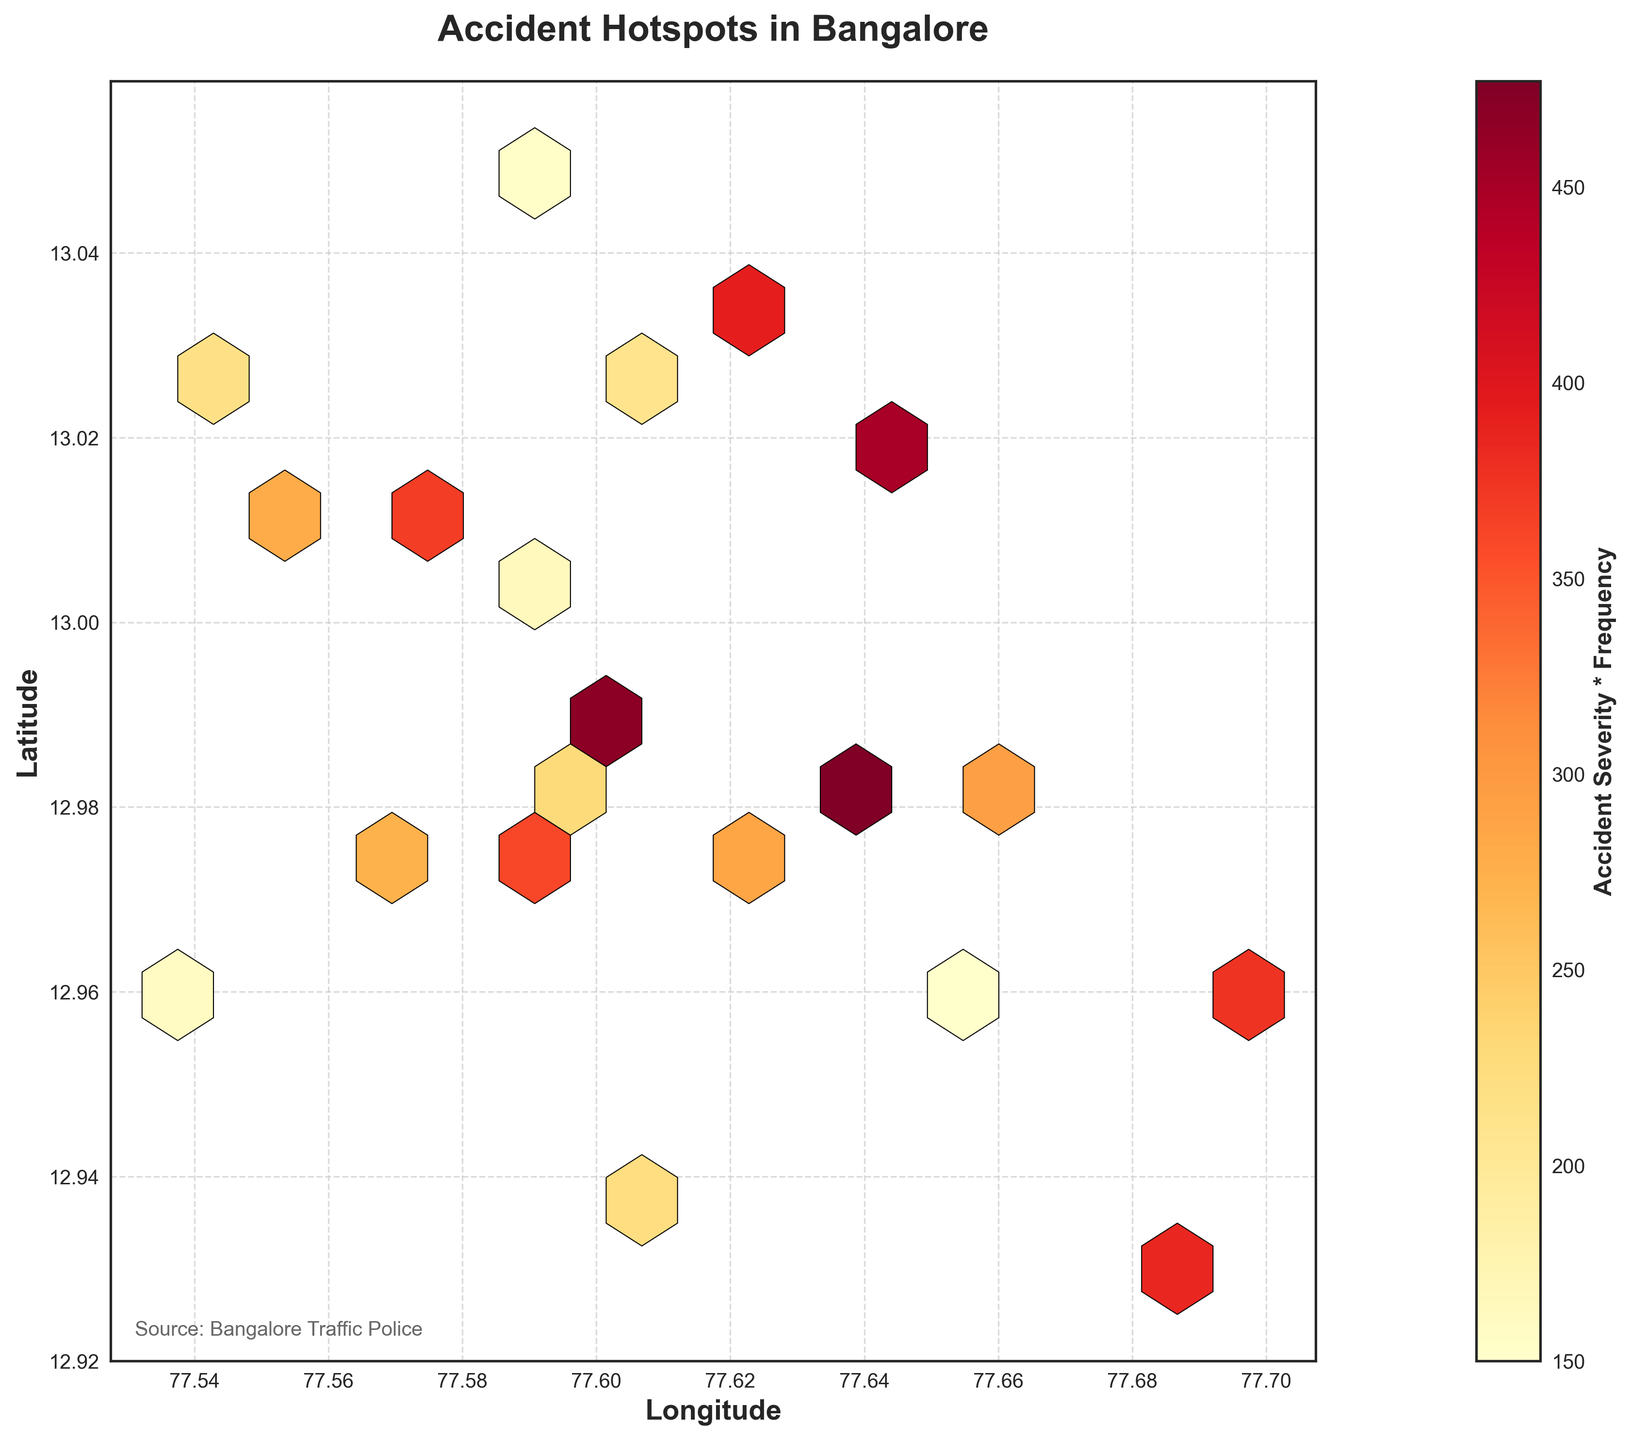What is the title of the figure? The title of the figure is located at the top and is usually in a larger font size than the other text on the plot. In this case, the title is 'Accident Hotspots in Bangalore'.
Answer: Accident Hotspots in Bangalore What does the color bar represent? The color bar is found on the side of the plot and is labeled 'Accident Severity * Frequency'. This indicates the color intensity correlates with the product of accident severity and frequency.
Answer: Accident Severity * Frequency What are the axis labels on the plot? The x-axis label is at the bottom of the plot, and the y-axis label is on the left side of the plot. They read 'Longitude' and 'Latitude' respectively.
Answer: Longitude and Latitude Where is the source of the data mentioned? The source of the data is usually noted at the bottom or side of the plot in smaller font. In this plot, it states, 'Source: Bangalore Traffic Police'.
Answer: Bangalore Traffic Police What area on the plot shows the highest concentration of accidents? To identify the area with the highest concentration of accidents, look for the densest cluster of hexagons with the most intense color. This is typically around the center of the plot.
Answer: Around the center Which range of hexbin plot colors indicates the highest severity and frequency? The color scale on the plot, moving from lighter to darker, shows increasing values. The darkest colors in the 'YlOrRd' color scale represent the highest severity and frequency.
Answer: Darkest colors Is there a notable clustering of accidents near any specific longitude? By examining the distribution of hexagons along the x-axis, clustering of accidents can be identified. A cluster near a specific longitude indicates a higher frequency around that area.
Answer: Yes, around 77.60 Compare the accident severity between the central and eastern areas of the plot. The central area shows a higher density of darker hexagons compared to the eastern side, indicating a higher accident severity and frequency in the center than in the east.
Answer: Higher in the center What is the approximate value for a high accident severity and frequency combination on the color bar? To find this, look at the top end of the color bar. The exact value depends on the plot but should be near the highest indicated value.
Answer: Near the top end of the color bar Do accident hotspots appear scattered or localized in the plot? By observing the hexbin distribution, check if the hexagons are spread out uniformly or concentrated in specific areas.
Answer: Localized in specific areas 